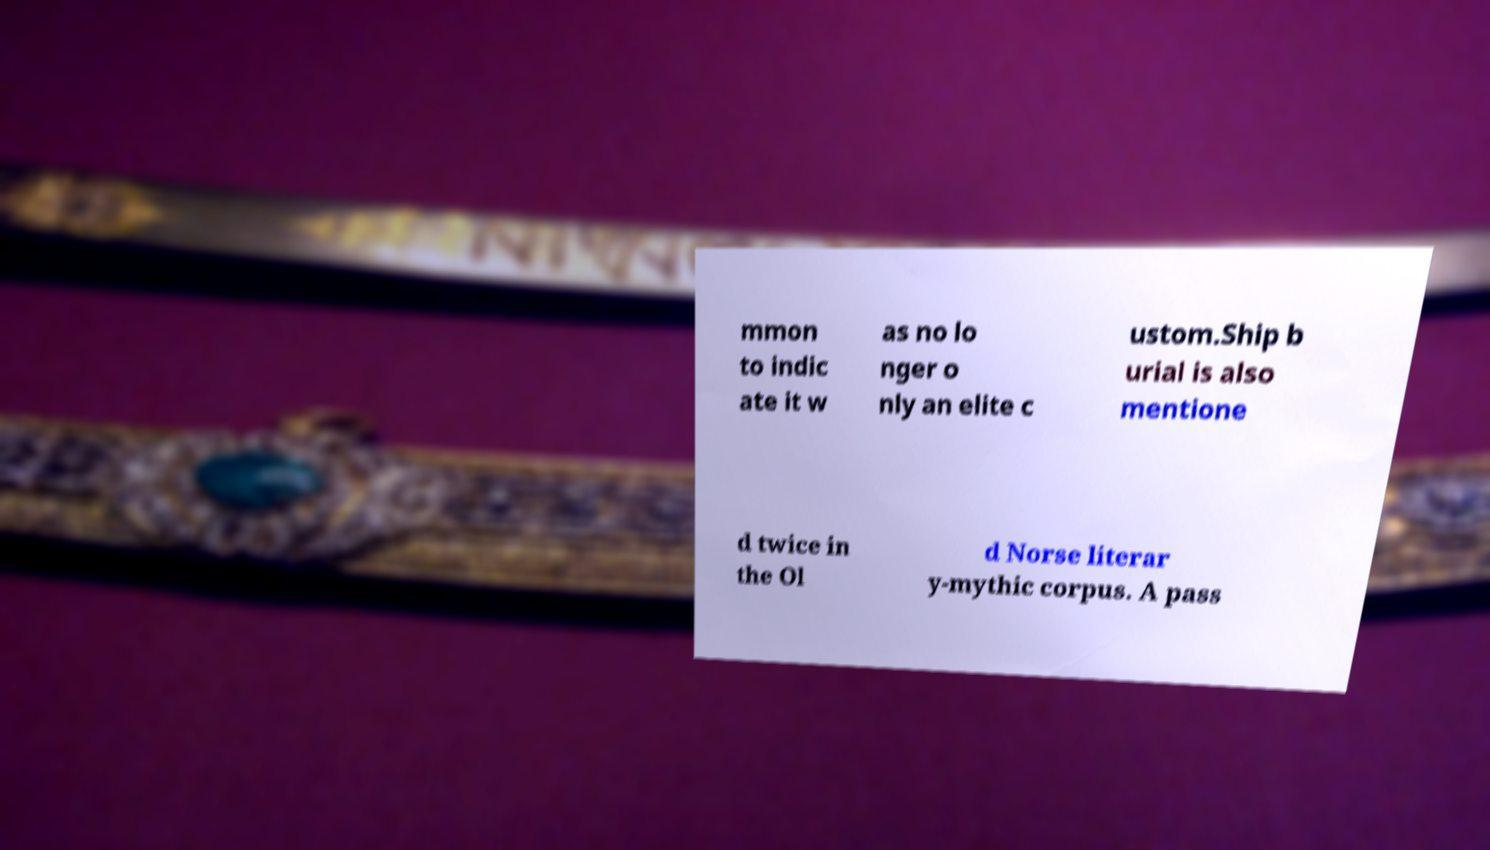For documentation purposes, I need the text within this image transcribed. Could you provide that? mmon to indic ate it w as no lo nger o nly an elite c ustom.Ship b urial is also mentione d twice in the Ol d Norse literar y-mythic corpus. A pass 